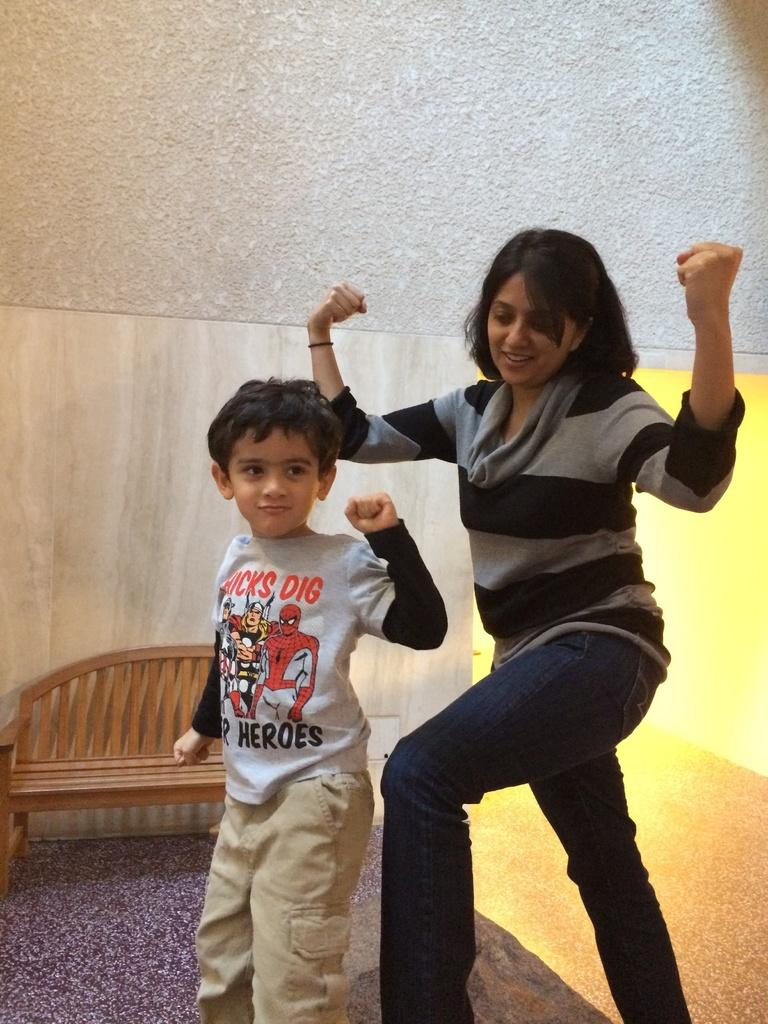Who is present in the image? There is a lady and a child in the image. What are the lady and child doing in the image? The lady and child are standing. What can be seen in the background of the image? There is a chair in the background of the image. What type of cable is being used by the child in the image? There is no cable present in the image; the child is simply standing with the lady. 